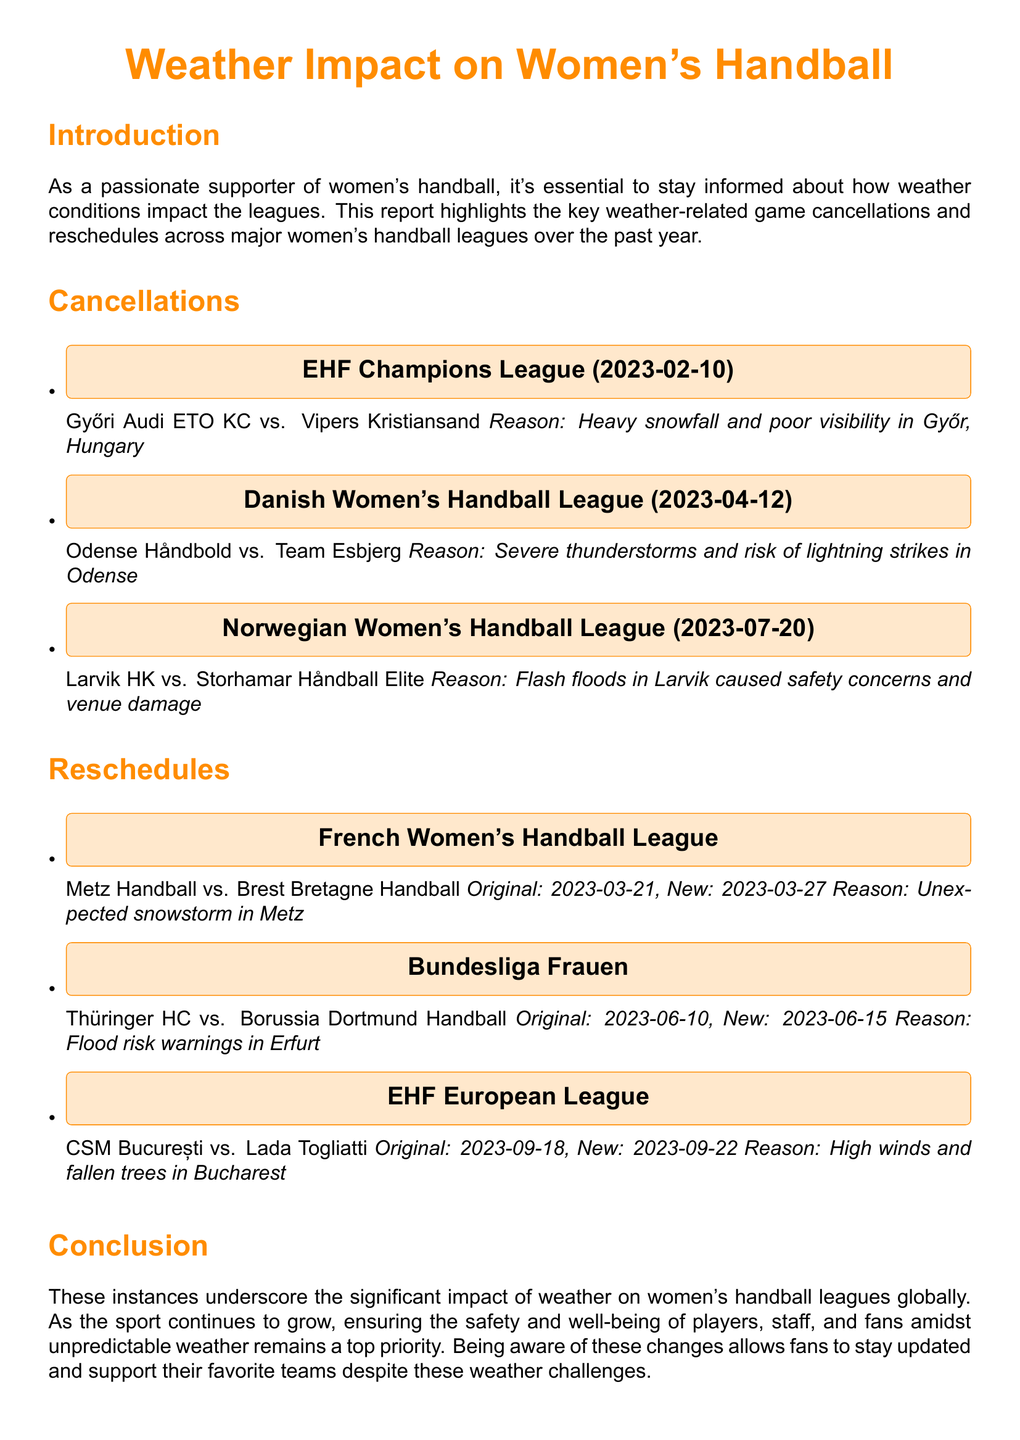What was the date of the cancellation for Győri Audi ETO KC vs. Vipers Kristiansand? The cancellation for this match was on 2023-02-10 as stated in the document.
Answer: 2023-02-10 What league experienced a cancellation due to thunderstorms? The document mentions that the Danish Women's Handball League had a cancellation due to severe thunderstorms.
Answer: Danish Women's Handball League How many games were canceled in the report? The cancellations section lists three games, indicating the total number of cancellations in the document.
Answer: 3 What was the original date for the rescheduled match between Metz Handball and Brest Bretagne Handball? The original date for this match is provided in the reschedules section of the document, stated as 2023-03-21.
Answer: 2023-03-21 What weather condition caused the rescheduling of the match between CSM București vs. Lada Togliatti? The document specifies that high winds and fallen trees were the reasons for the rescheduling of this match.
Answer: High winds and fallen trees How many days later was the match Thüringer HC vs. Borussia Dortmund Handball rescheduled? The reschedule from 2023-06-10 to 2023-06-15 indicates a change of five days.
Answer: 5 days What was the reason for the cancellation of Larvik HK vs. Storhamar Håndball Elite? The document states that flash floods in Larvik caused safety concerns and venue damage, which is the reason for this cancellation.
Answer: Flash floods Which league had to deal with a snowstorm leading to a schedule change? The French Women's Handball League had to deal with an unexpected snowstorm that led to the reschedule.
Answer: French Women's Handball League 